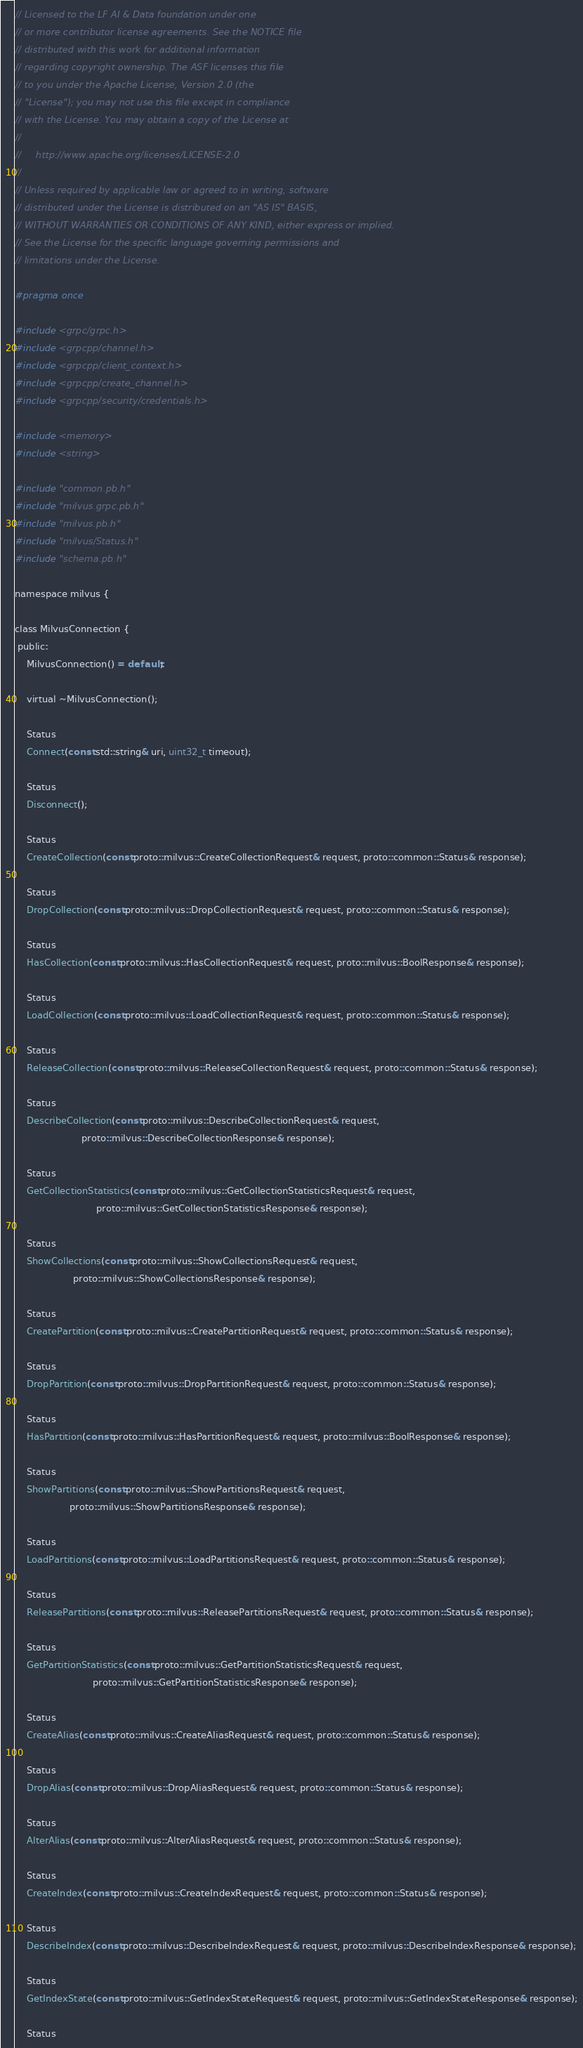Convert code to text. <code><loc_0><loc_0><loc_500><loc_500><_C_>// Licensed to the LF AI & Data foundation under one
// or more contributor license agreements. See the NOTICE file
// distributed with this work for additional information
// regarding copyright ownership. The ASF licenses this file
// to you under the Apache License, Version 2.0 (the
// "License"); you may not use this file except in compliance
// with the License. You may obtain a copy of the License at
//
//     http://www.apache.org/licenses/LICENSE-2.0
//
// Unless required by applicable law or agreed to in writing, software
// distributed under the License is distributed on an "AS IS" BASIS,
// WITHOUT WARRANTIES OR CONDITIONS OF ANY KIND, either express or implied.
// See the License for the specific language governing permissions and
// limitations under the License.

#pragma once

#include <grpc/grpc.h>
#include <grpcpp/channel.h>
#include <grpcpp/client_context.h>
#include <grpcpp/create_channel.h>
#include <grpcpp/security/credentials.h>

#include <memory>
#include <string>

#include "common.pb.h"
#include "milvus.grpc.pb.h"
#include "milvus.pb.h"
#include "milvus/Status.h"
#include "schema.pb.h"

namespace milvus {

class MilvusConnection {
 public:
    MilvusConnection() = default;

    virtual ~MilvusConnection();

    Status
    Connect(const std::string& uri, uint32_t timeout);

    Status
    Disconnect();

    Status
    CreateCollection(const proto::milvus::CreateCollectionRequest& request, proto::common::Status& response);

    Status
    DropCollection(const proto::milvus::DropCollectionRequest& request, proto::common::Status& response);

    Status
    HasCollection(const proto::milvus::HasCollectionRequest& request, proto::milvus::BoolResponse& response);

    Status
    LoadCollection(const proto::milvus::LoadCollectionRequest& request, proto::common::Status& response);

    Status
    ReleaseCollection(const proto::milvus::ReleaseCollectionRequest& request, proto::common::Status& response);

    Status
    DescribeCollection(const proto::milvus::DescribeCollectionRequest& request,
                       proto::milvus::DescribeCollectionResponse& response);

    Status
    GetCollectionStatistics(const proto::milvus::GetCollectionStatisticsRequest& request,
                            proto::milvus::GetCollectionStatisticsResponse& response);

    Status
    ShowCollections(const proto::milvus::ShowCollectionsRequest& request,
                    proto::milvus::ShowCollectionsResponse& response);

    Status
    CreatePartition(const proto::milvus::CreatePartitionRequest& request, proto::common::Status& response);

    Status
    DropPartition(const proto::milvus::DropPartitionRequest& request, proto::common::Status& response);

    Status
    HasPartition(const proto::milvus::HasPartitionRequest& request, proto::milvus::BoolResponse& response);

    Status
    ShowPartitions(const proto::milvus::ShowPartitionsRequest& request,
                   proto::milvus::ShowPartitionsResponse& response);

    Status
    LoadPartitions(const proto::milvus::LoadPartitionsRequest& request, proto::common::Status& response);

    Status
    ReleasePartitions(const proto::milvus::ReleasePartitionsRequest& request, proto::common::Status& response);

    Status
    GetPartitionStatistics(const proto::milvus::GetPartitionStatisticsRequest& request,
                           proto::milvus::GetPartitionStatisticsResponse& response);

    Status
    CreateAlias(const proto::milvus::CreateAliasRequest& request, proto::common::Status& response);

    Status
    DropAlias(const proto::milvus::DropAliasRequest& request, proto::common::Status& response);

    Status
    AlterAlias(const proto::milvus::AlterAliasRequest& request, proto::common::Status& response);

    Status
    CreateIndex(const proto::milvus::CreateIndexRequest& request, proto::common::Status& response);

    Status
    DescribeIndex(const proto::milvus::DescribeIndexRequest& request, proto::milvus::DescribeIndexResponse& response);

    Status
    GetIndexState(const proto::milvus::GetIndexStateRequest& request, proto::milvus::GetIndexStateResponse& response);

    Status</code> 